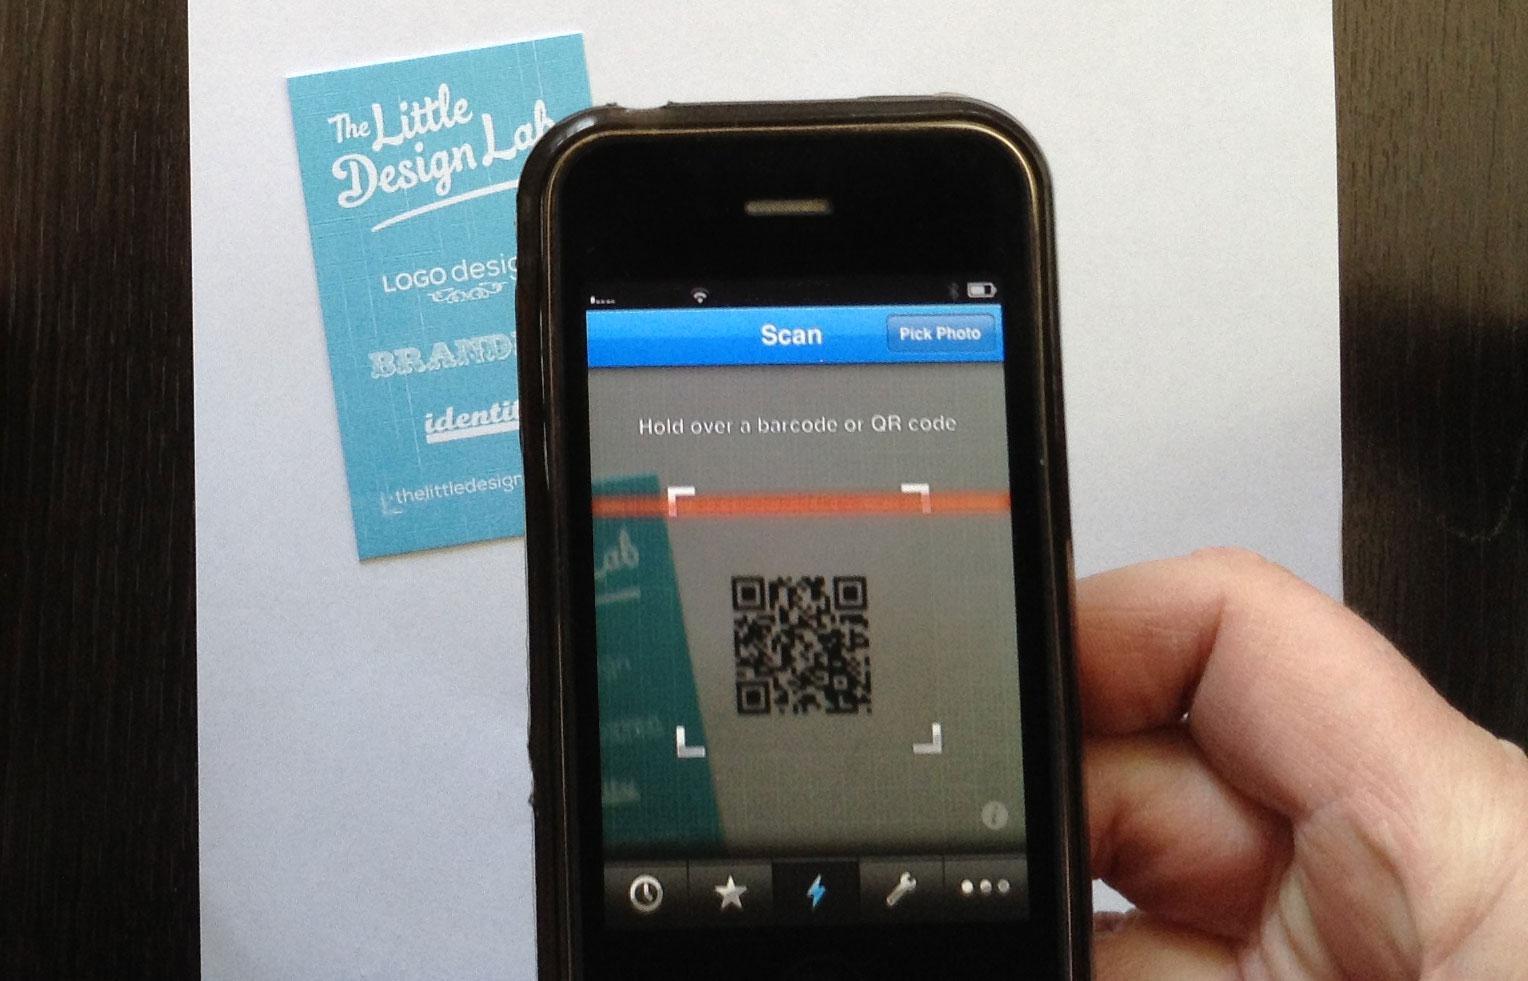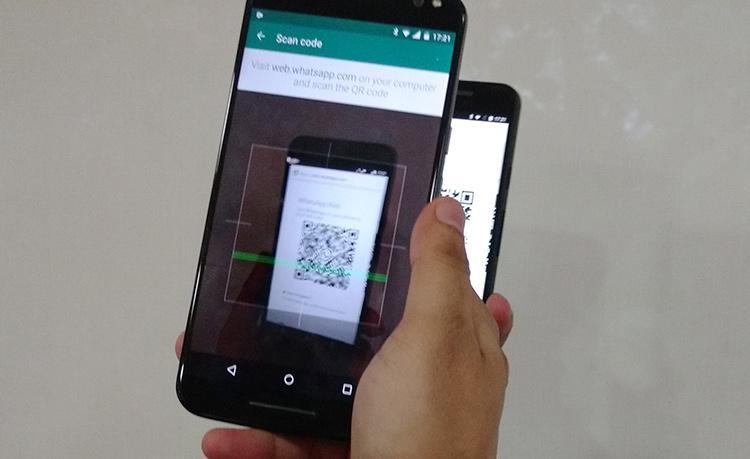The first image is the image on the left, the second image is the image on the right. Analyze the images presented: Is the assertion "There are three smartphones." valid? Answer yes or no. Yes. The first image is the image on the left, the second image is the image on the right. Given the left and right images, does the statement "All of the phones have a QR Code on the screen." hold true? Answer yes or no. Yes. 